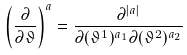<formula> <loc_0><loc_0><loc_500><loc_500>\left ( \frac { \partial } { \partial \vartheta } \right ) ^ { a } = \frac { \partial ^ { | a | } } { \partial ( \vartheta ^ { 1 } ) ^ { a _ { 1 } } \partial ( \vartheta ^ { 2 } ) ^ { a _ { 2 } } }</formula> 